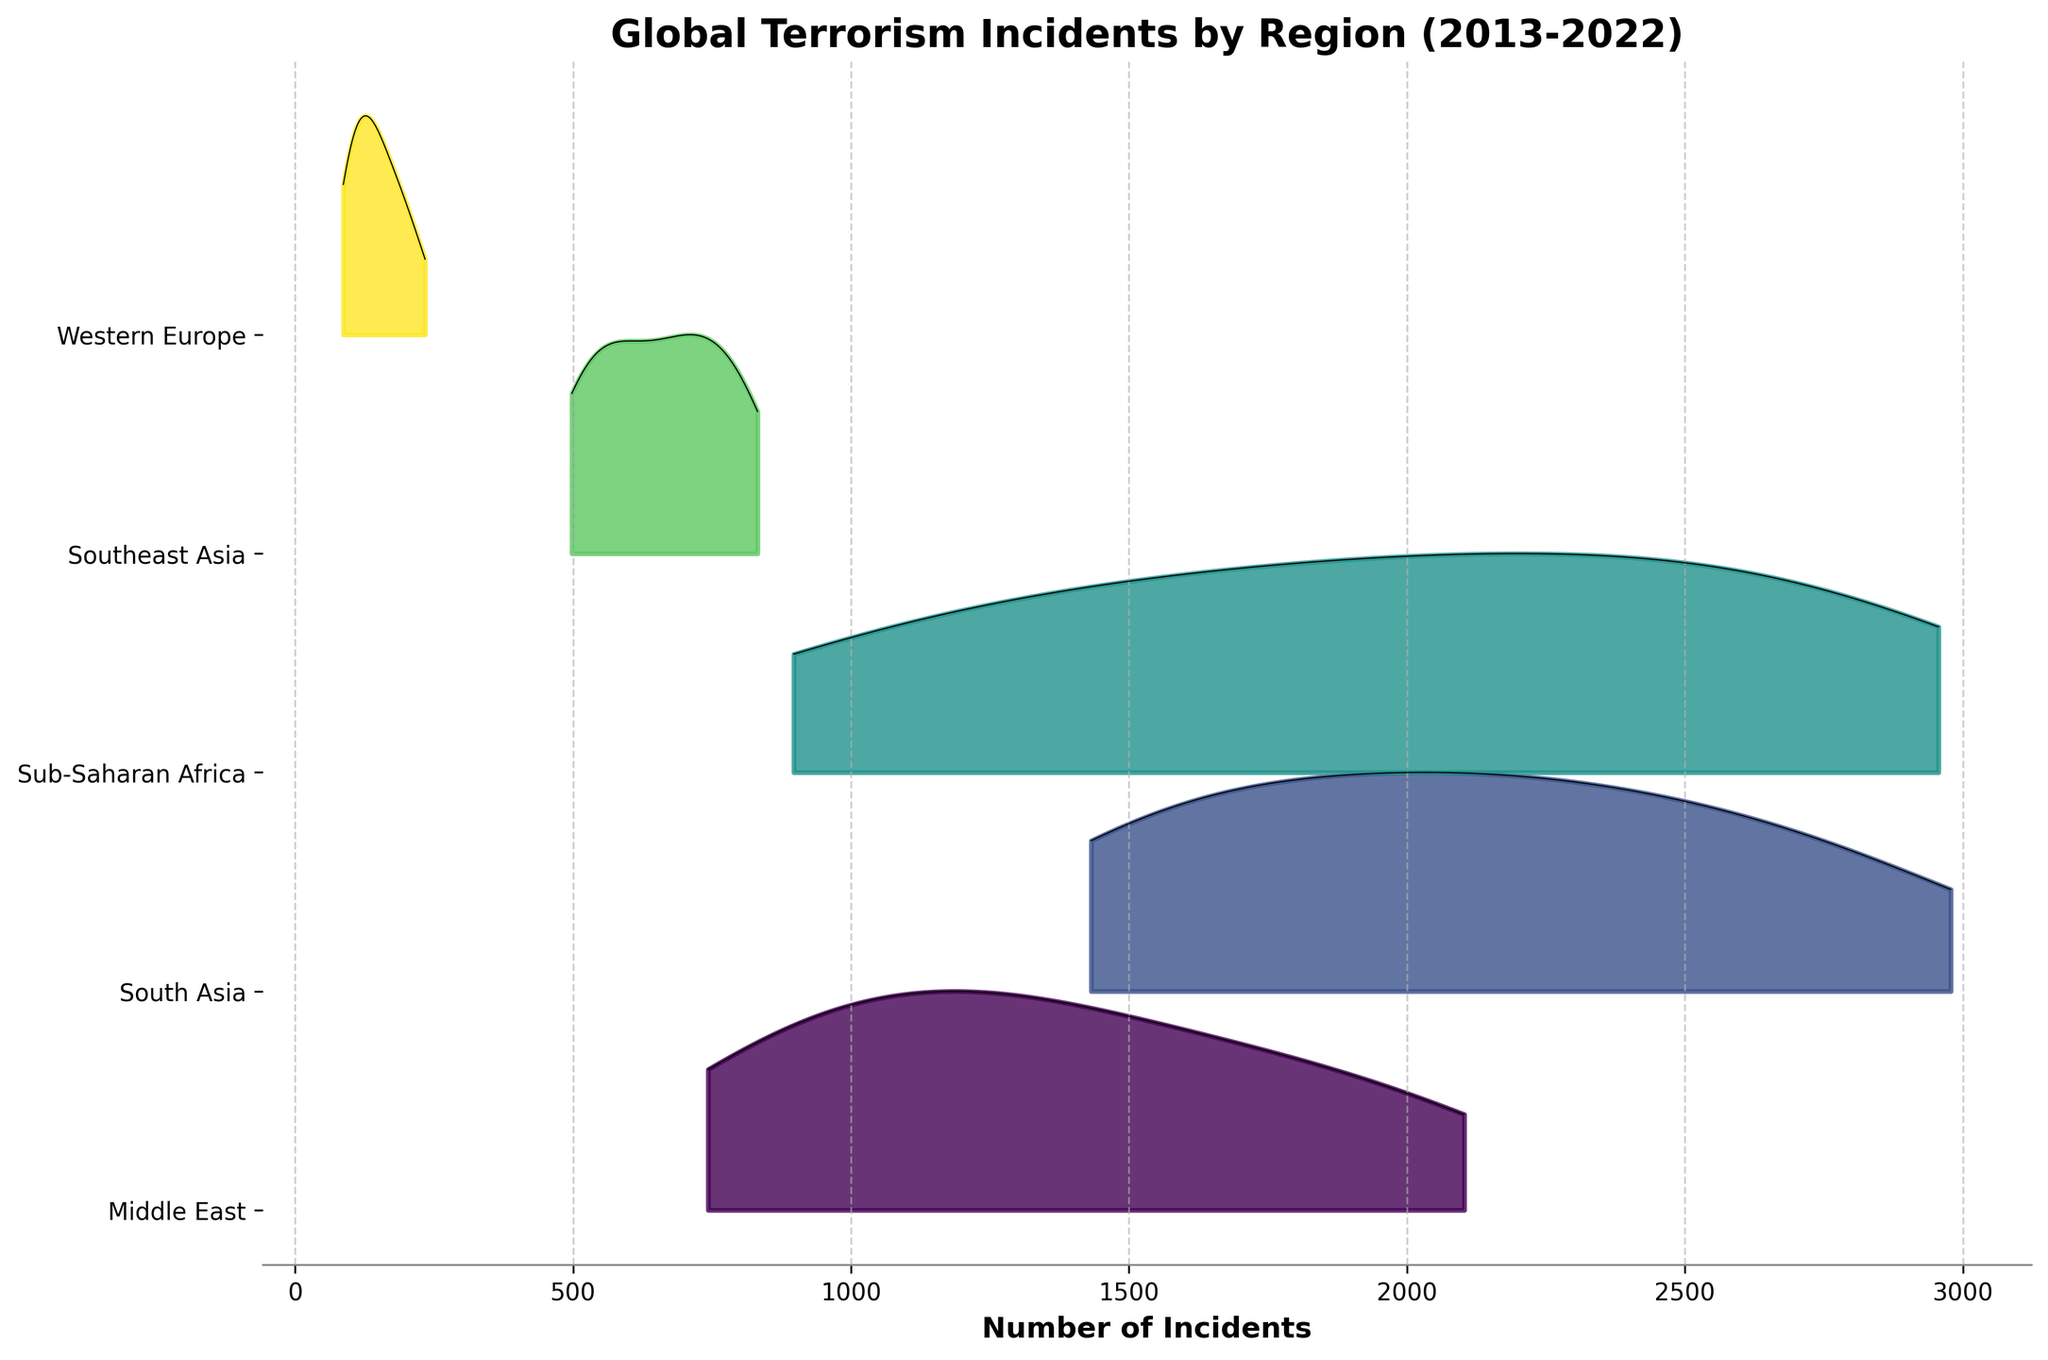What's the title of the figure? The title is located at the top of the figure and is usually displayed in prominent text.
Answer: Global Terrorism Incidents by Region (2013-2022) What does the x-axis represent? The x-axis typically runs horizontally across the bottom of the figure. By reading the label, you can identify what it represents.
Answer: Number of Incidents Which region had the highest number of incidents overall? By examining the ridgeline plots, you can see which region's distribution has the highest peaks, indicating higher numbers of incidents.
Answer: South Asia How does the trend of incidents in the Middle East compare to Western Europe from 2013 to 2022? To compare trends, observe the overall shape and position of the ridgelines for both regions over the years. The Middle East shows a decreasing trend, whereas Western Europe has significantly lower peaks throughout, indicating fewer incidents overall.
Answer: Middle East shows a decreasing trend, Western Europe consistently low Which regions show an increasing trend in the number of incidents from 2013 to 2022? To identify increasing trends, examine the ridgeline plots for each region and look for those where the peaks are higher towards the latter years compared to the earlier years.
Answer: Sub-Saharan Africa In which year did the Middle East experience the peak number of incidents? Within the ridgeline for the Middle East, identify the year corresponding to the highest peak on the plot.
Answer: 2015 Between Sub-Saharan Africa and Southeast Asia, which region had more incidents in 2016? Compare the heights of the ridgelines for both regions on the 2016 marker. The region with the higher peak had more incidents.
Answer: Sub-Saharan Africa Describe the general trend for incidents in South Asia from 2013 to 2022. Observe the shifts and heights of peaks for South Asia over the years to describe the trend. South Asia shows a peak around 2015, followed by a gradual decrease.
Answer: Increasing until 2015, then gradually decreasing Which year recorded the lowest incidents for Western Europe? Look at the lowest point or the smallest peak within the ridgeline representing Western Europe.
Answer: 2022 Which regions have a peak in the middle years (2015-2017) and a decline afterward? Identify and compare the shapes of the ridgeline plots for the specified regions during the middle years, noting their trend before and after this period.
Answer: Middle East and South Asia 